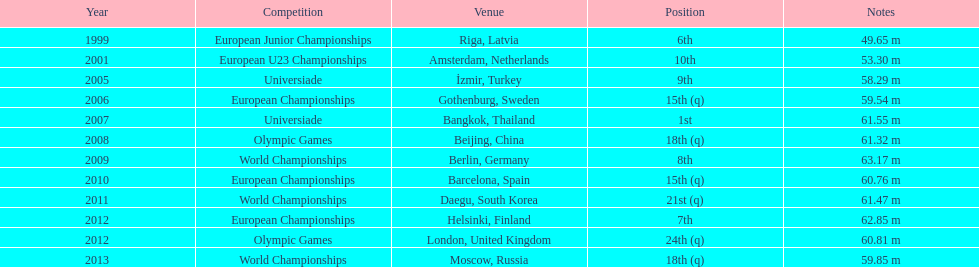During what listed year was the 5 2001. 